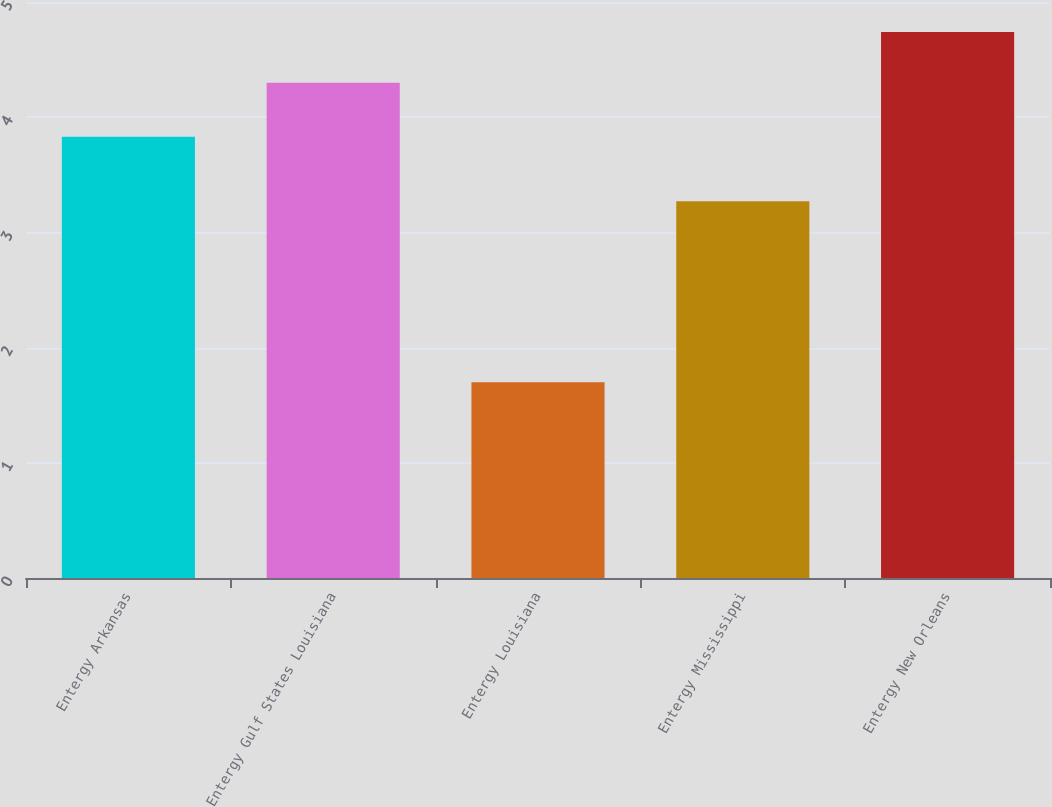<chart> <loc_0><loc_0><loc_500><loc_500><bar_chart><fcel>Entergy Arkansas<fcel>Entergy Gulf States Louisiana<fcel>Entergy Louisiana<fcel>Entergy Mississippi<fcel>Entergy New Orleans<nl><fcel>3.83<fcel>4.3<fcel>1.7<fcel>3.27<fcel>4.74<nl></chart> 